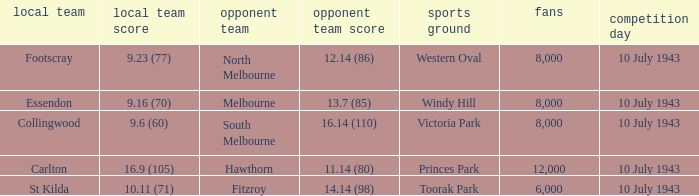When the Venue was victoria park, what was the Away team score? 16.14 (110). 